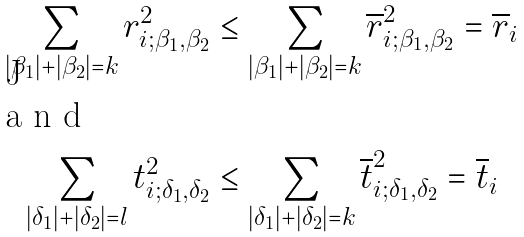Convert formula to latex. <formula><loc_0><loc_0><loc_500><loc_500>\sum _ { | \beta _ { 1 } | + | \beta _ { 2 } | = k } r _ { i ; \beta _ { 1 } , \beta _ { 2 } } ^ { 2 } & \leq \sum _ { | \beta _ { 1 } | + | \beta _ { 2 } | = k } \overline { r } _ { i ; \beta _ { 1 } , \beta _ { 2 } } ^ { 2 } = \overline { r } _ { i } \\ \intertext { a n d } \sum _ { | \delta _ { 1 } | + | \delta _ { 2 } | = l } t _ { i ; \delta _ { 1 } , \delta _ { 2 } } ^ { 2 } & \leq \sum _ { | \delta _ { 1 } | + | \delta _ { 2 } | = k } \overline { t } _ { i ; \delta _ { 1 } , \delta _ { 2 } } ^ { 2 } = \overline { t } _ { i }</formula> 